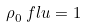Convert formula to latex. <formula><loc_0><loc_0><loc_500><loc_500>\rho _ { 0 } ^ { \ } f l u = 1</formula> 